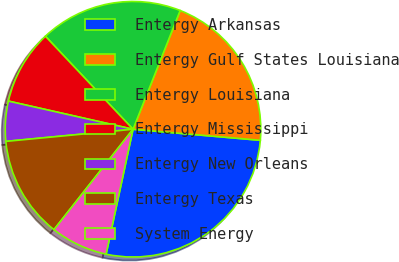Convert chart. <chart><loc_0><loc_0><loc_500><loc_500><pie_chart><fcel>Entergy Arkansas<fcel>Entergy Gulf States Louisiana<fcel>Entergy Louisiana<fcel>Entergy Mississippi<fcel>Entergy New Orleans<fcel>Entergy Texas<fcel>System Energy<nl><fcel>27.0%<fcel>20.36%<fcel>18.04%<fcel>9.44%<fcel>5.05%<fcel>12.87%<fcel>7.24%<nl></chart> 